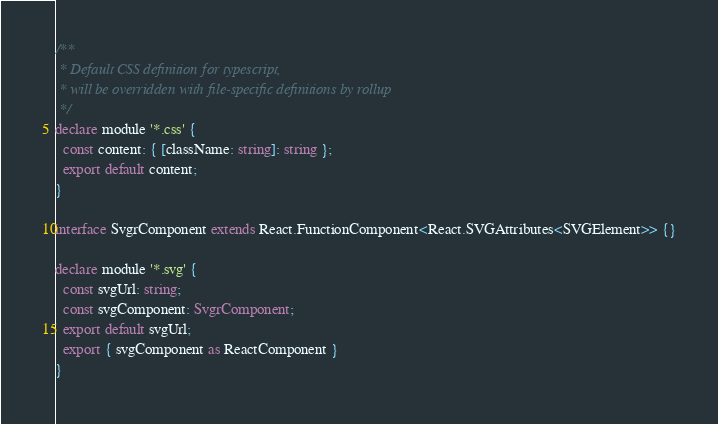<code> <loc_0><loc_0><loc_500><loc_500><_TypeScript_>/**
 * Default CSS definition for typescript,
 * will be overridden with file-specific definitions by rollup
 */
declare module '*.css' {
  const content: { [className: string]: string };
  export default content;
}

interface SvgrComponent extends React.FunctionComponent<React.SVGAttributes<SVGElement>> {}

declare module '*.svg' {
  const svgUrl: string;
  const svgComponent: SvgrComponent;
  export default svgUrl;
  export { svgComponent as ReactComponent }
}
</code> 